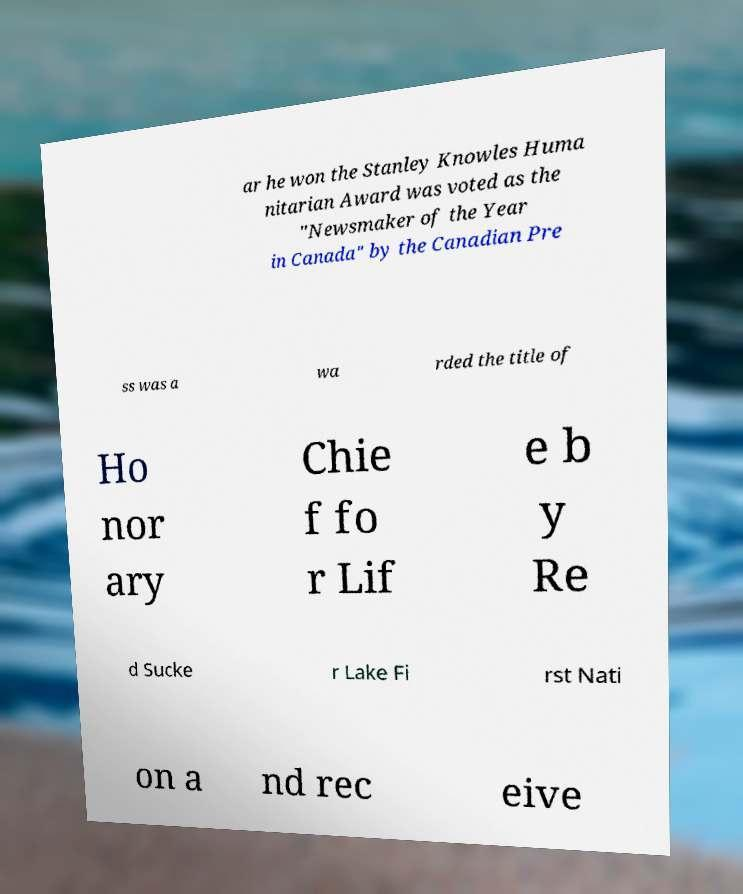There's text embedded in this image that I need extracted. Can you transcribe it verbatim? ar he won the Stanley Knowles Huma nitarian Award was voted as the "Newsmaker of the Year in Canada" by the Canadian Pre ss was a wa rded the title of Ho nor ary Chie f fo r Lif e b y Re d Sucke r Lake Fi rst Nati on a nd rec eive 